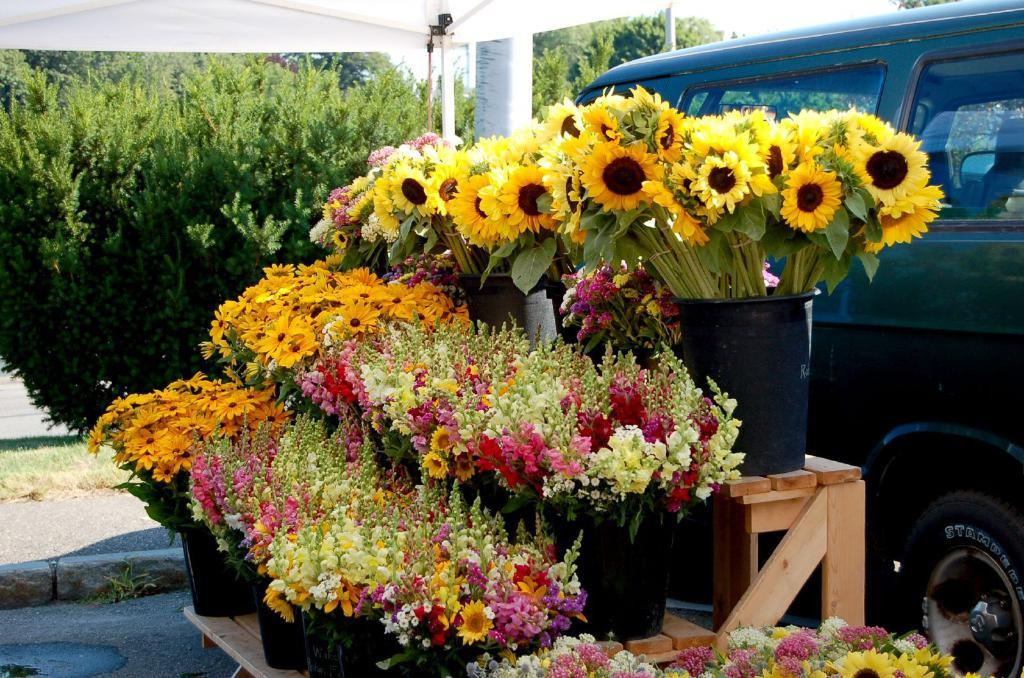What is the main subject of the image? The main subject of the image is the flower pots arranged on a wooden table. Where is the table located in relation to the tree? The table is located beside the tree. What can be seen in the background of the image? There is a car visible in the background of the image. What type of corn is being requested by the tree in the image? There is no corn or request present in the image; it features flower pots on a table beside a tree and a car in the background. 